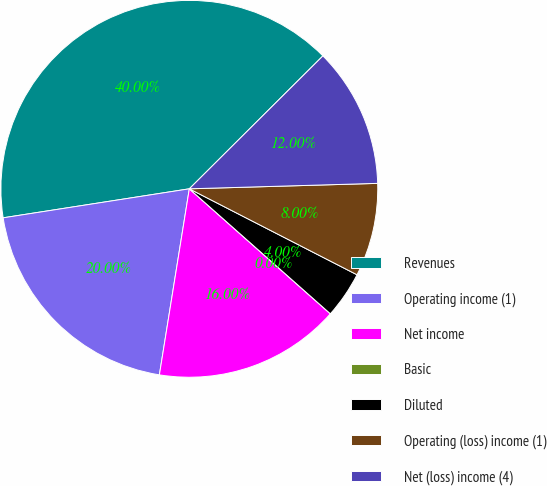<chart> <loc_0><loc_0><loc_500><loc_500><pie_chart><fcel>Revenues<fcel>Operating income (1)<fcel>Net income<fcel>Basic<fcel>Diluted<fcel>Operating (loss) income (1)<fcel>Net (loss) income (4)<nl><fcel>40.0%<fcel>20.0%<fcel>16.0%<fcel>0.0%<fcel>4.0%<fcel>8.0%<fcel>12.0%<nl></chart> 